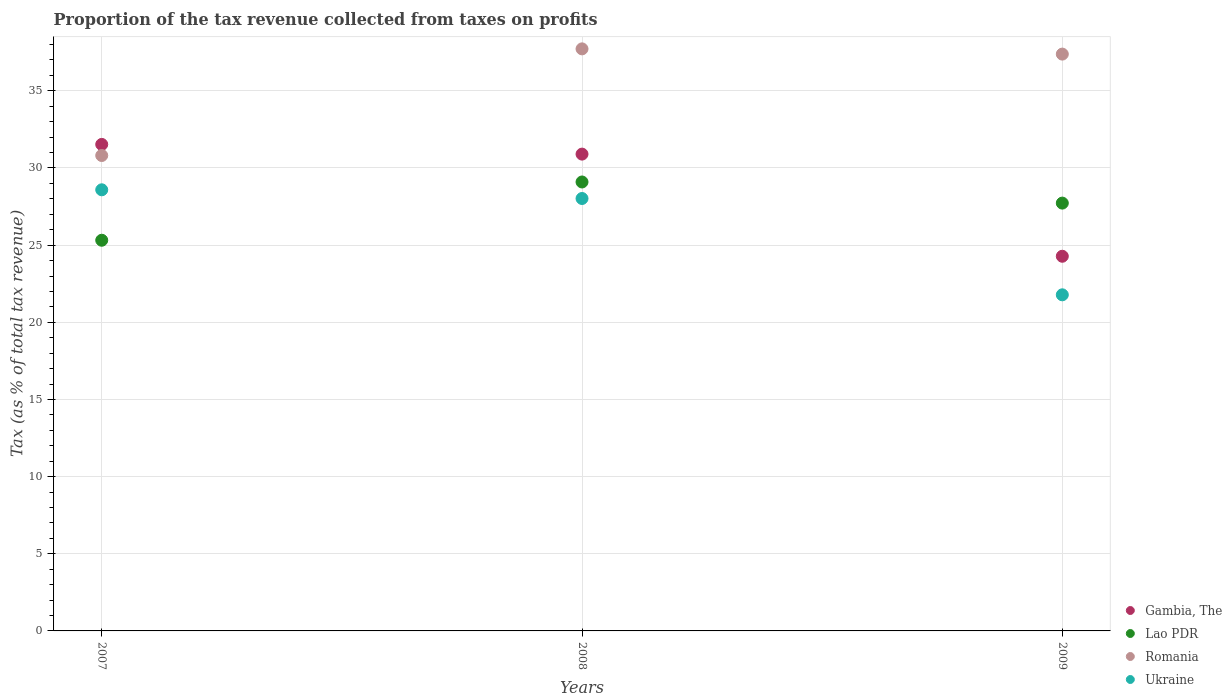Is the number of dotlines equal to the number of legend labels?
Make the answer very short. Yes. What is the proportion of the tax revenue collected in Gambia, The in 2009?
Provide a short and direct response. 24.28. Across all years, what is the maximum proportion of the tax revenue collected in Romania?
Offer a terse response. 37.72. Across all years, what is the minimum proportion of the tax revenue collected in Romania?
Keep it short and to the point. 30.81. In which year was the proportion of the tax revenue collected in Ukraine maximum?
Provide a short and direct response. 2007. In which year was the proportion of the tax revenue collected in Gambia, The minimum?
Ensure brevity in your answer.  2009. What is the total proportion of the tax revenue collected in Gambia, The in the graph?
Give a very brief answer. 86.71. What is the difference between the proportion of the tax revenue collected in Romania in 2008 and that in 2009?
Provide a short and direct response. 0.34. What is the difference between the proportion of the tax revenue collected in Lao PDR in 2009 and the proportion of the tax revenue collected in Romania in 2008?
Your answer should be very brief. -9.99. What is the average proportion of the tax revenue collected in Romania per year?
Your answer should be compact. 35.3. In the year 2008, what is the difference between the proportion of the tax revenue collected in Lao PDR and proportion of the tax revenue collected in Ukraine?
Ensure brevity in your answer.  1.07. What is the ratio of the proportion of the tax revenue collected in Romania in 2008 to that in 2009?
Ensure brevity in your answer.  1.01. Is the proportion of the tax revenue collected in Ukraine in 2007 less than that in 2008?
Keep it short and to the point. No. Is the difference between the proportion of the tax revenue collected in Lao PDR in 2008 and 2009 greater than the difference between the proportion of the tax revenue collected in Ukraine in 2008 and 2009?
Your answer should be very brief. No. What is the difference between the highest and the second highest proportion of the tax revenue collected in Lao PDR?
Offer a terse response. 1.37. What is the difference between the highest and the lowest proportion of the tax revenue collected in Romania?
Offer a very short reply. 6.91. Is the sum of the proportion of the tax revenue collected in Gambia, The in 2007 and 2009 greater than the maximum proportion of the tax revenue collected in Lao PDR across all years?
Give a very brief answer. Yes. Does the proportion of the tax revenue collected in Gambia, The monotonically increase over the years?
Your answer should be very brief. No. Is the proportion of the tax revenue collected in Ukraine strictly greater than the proportion of the tax revenue collected in Gambia, The over the years?
Ensure brevity in your answer.  No. Is the proportion of the tax revenue collected in Gambia, The strictly less than the proportion of the tax revenue collected in Romania over the years?
Offer a very short reply. No. How many dotlines are there?
Give a very brief answer. 4. How many years are there in the graph?
Ensure brevity in your answer.  3. Are the values on the major ticks of Y-axis written in scientific E-notation?
Ensure brevity in your answer.  No. Does the graph contain grids?
Provide a succinct answer. Yes. How are the legend labels stacked?
Provide a succinct answer. Vertical. What is the title of the graph?
Provide a succinct answer. Proportion of the tax revenue collected from taxes on profits. What is the label or title of the X-axis?
Offer a very short reply. Years. What is the label or title of the Y-axis?
Offer a terse response. Tax (as % of total tax revenue). What is the Tax (as % of total tax revenue) of Gambia, The in 2007?
Keep it short and to the point. 31.53. What is the Tax (as % of total tax revenue) in Lao PDR in 2007?
Your answer should be compact. 25.32. What is the Tax (as % of total tax revenue) of Romania in 2007?
Offer a terse response. 30.81. What is the Tax (as % of total tax revenue) in Ukraine in 2007?
Offer a very short reply. 28.59. What is the Tax (as % of total tax revenue) of Gambia, The in 2008?
Your answer should be very brief. 30.9. What is the Tax (as % of total tax revenue) in Lao PDR in 2008?
Your answer should be compact. 29.09. What is the Tax (as % of total tax revenue) of Romania in 2008?
Offer a terse response. 37.72. What is the Tax (as % of total tax revenue) in Ukraine in 2008?
Give a very brief answer. 28.02. What is the Tax (as % of total tax revenue) of Gambia, The in 2009?
Keep it short and to the point. 24.28. What is the Tax (as % of total tax revenue) of Lao PDR in 2009?
Your answer should be very brief. 27.72. What is the Tax (as % of total tax revenue) in Romania in 2009?
Make the answer very short. 37.38. What is the Tax (as % of total tax revenue) of Ukraine in 2009?
Offer a very short reply. 21.78. Across all years, what is the maximum Tax (as % of total tax revenue) of Gambia, The?
Provide a succinct answer. 31.53. Across all years, what is the maximum Tax (as % of total tax revenue) of Lao PDR?
Your answer should be compact. 29.09. Across all years, what is the maximum Tax (as % of total tax revenue) of Romania?
Provide a short and direct response. 37.72. Across all years, what is the maximum Tax (as % of total tax revenue) in Ukraine?
Provide a short and direct response. 28.59. Across all years, what is the minimum Tax (as % of total tax revenue) of Gambia, The?
Provide a short and direct response. 24.28. Across all years, what is the minimum Tax (as % of total tax revenue) of Lao PDR?
Provide a succinct answer. 25.32. Across all years, what is the minimum Tax (as % of total tax revenue) of Romania?
Ensure brevity in your answer.  30.81. Across all years, what is the minimum Tax (as % of total tax revenue) in Ukraine?
Ensure brevity in your answer.  21.78. What is the total Tax (as % of total tax revenue) of Gambia, The in the graph?
Make the answer very short. 86.71. What is the total Tax (as % of total tax revenue) in Lao PDR in the graph?
Offer a very short reply. 82.14. What is the total Tax (as % of total tax revenue) of Romania in the graph?
Offer a terse response. 105.91. What is the total Tax (as % of total tax revenue) in Ukraine in the graph?
Provide a succinct answer. 78.39. What is the difference between the Tax (as % of total tax revenue) of Gambia, The in 2007 and that in 2008?
Your answer should be very brief. 0.63. What is the difference between the Tax (as % of total tax revenue) in Lao PDR in 2007 and that in 2008?
Keep it short and to the point. -3.78. What is the difference between the Tax (as % of total tax revenue) of Romania in 2007 and that in 2008?
Your answer should be compact. -6.91. What is the difference between the Tax (as % of total tax revenue) of Ukraine in 2007 and that in 2008?
Ensure brevity in your answer.  0.56. What is the difference between the Tax (as % of total tax revenue) in Gambia, The in 2007 and that in 2009?
Offer a very short reply. 7.25. What is the difference between the Tax (as % of total tax revenue) in Lao PDR in 2007 and that in 2009?
Keep it short and to the point. -2.41. What is the difference between the Tax (as % of total tax revenue) of Romania in 2007 and that in 2009?
Give a very brief answer. -6.57. What is the difference between the Tax (as % of total tax revenue) in Ukraine in 2007 and that in 2009?
Provide a short and direct response. 6.81. What is the difference between the Tax (as % of total tax revenue) in Gambia, The in 2008 and that in 2009?
Ensure brevity in your answer.  6.62. What is the difference between the Tax (as % of total tax revenue) in Lao PDR in 2008 and that in 2009?
Ensure brevity in your answer.  1.37. What is the difference between the Tax (as % of total tax revenue) of Romania in 2008 and that in 2009?
Keep it short and to the point. 0.34. What is the difference between the Tax (as % of total tax revenue) in Ukraine in 2008 and that in 2009?
Provide a succinct answer. 6.24. What is the difference between the Tax (as % of total tax revenue) in Gambia, The in 2007 and the Tax (as % of total tax revenue) in Lao PDR in 2008?
Provide a succinct answer. 2.43. What is the difference between the Tax (as % of total tax revenue) of Gambia, The in 2007 and the Tax (as % of total tax revenue) of Romania in 2008?
Offer a very short reply. -6.19. What is the difference between the Tax (as % of total tax revenue) of Gambia, The in 2007 and the Tax (as % of total tax revenue) of Ukraine in 2008?
Your answer should be very brief. 3.51. What is the difference between the Tax (as % of total tax revenue) of Lao PDR in 2007 and the Tax (as % of total tax revenue) of Romania in 2008?
Provide a short and direct response. -12.4. What is the difference between the Tax (as % of total tax revenue) in Lao PDR in 2007 and the Tax (as % of total tax revenue) in Ukraine in 2008?
Your answer should be very brief. -2.71. What is the difference between the Tax (as % of total tax revenue) of Romania in 2007 and the Tax (as % of total tax revenue) of Ukraine in 2008?
Provide a short and direct response. 2.79. What is the difference between the Tax (as % of total tax revenue) of Gambia, The in 2007 and the Tax (as % of total tax revenue) of Lao PDR in 2009?
Keep it short and to the point. 3.8. What is the difference between the Tax (as % of total tax revenue) in Gambia, The in 2007 and the Tax (as % of total tax revenue) in Romania in 2009?
Give a very brief answer. -5.85. What is the difference between the Tax (as % of total tax revenue) of Gambia, The in 2007 and the Tax (as % of total tax revenue) of Ukraine in 2009?
Ensure brevity in your answer.  9.75. What is the difference between the Tax (as % of total tax revenue) of Lao PDR in 2007 and the Tax (as % of total tax revenue) of Romania in 2009?
Offer a very short reply. -12.06. What is the difference between the Tax (as % of total tax revenue) of Lao PDR in 2007 and the Tax (as % of total tax revenue) of Ukraine in 2009?
Provide a short and direct response. 3.54. What is the difference between the Tax (as % of total tax revenue) in Romania in 2007 and the Tax (as % of total tax revenue) in Ukraine in 2009?
Your answer should be compact. 9.03. What is the difference between the Tax (as % of total tax revenue) in Gambia, The in 2008 and the Tax (as % of total tax revenue) in Lao PDR in 2009?
Provide a succinct answer. 3.17. What is the difference between the Tax (as % of total tax revenue) of Gambia, The in 2008 and the Tax (as % of total tax revenue) of Romania in 2009?
Offer a very short reply. -6.48. What is the difference between the Tax (as % of total tax revenue) in Gambia, The in 2008 and the Tax (as % of total tax revenue) in Ukraine in 2009?
Offer a terse response. 9.12. What is the difference between the Tax (as % of total tax revenue) of Lao PDR in 2008 and the Tax (as % of total tax revenue) of Romania in 2009?
Give a very brief answer. -8.29. What is the difference between the Tax (as % of total tax revenue) in Lao PDR in 2008 and the Tax (as % of total tax revenue) in Ukraine in 2009?
Offer a terse response. 7.31. What is the difference between the Tax (as % of total tax revenue) in Romania in 2008 and the Tax (as % of total tax revenue) in Ukraine in 2009?
Your response must be concise. 15.94. What is the average Tax (as % of total tax revenue) of Gambia, The per year?
Your answer should be compact. 28.9. What is the average Tax (as % of total tax revenue) of Lao PDR per year?
Keep it short and to the point. 27.38. What is the average Tax (as % of total tax revenue) in Romania per year?
Your response must be concise. 35.3. What is the average Tax (as % of total tax revenue) of Ukraine per year?
Provide a short and direct response. 26.13. In the year 2007, what is the difference between the Tax (as % of total tax revenue) of Gambia, The and Tax (as % of total tax revenue) of Lao PDR?
Keep it short and to the point. 6.21. In the year 2007, what is the difference between the Tax (as % of total tax revenue) in Gambia, The and Tax (as % of total tax revenue) in Romania?
Offer a very short reply. 0.72. In the year 2007, what is the difference between the Tax (as % of total tax revenue) in Gambia, The and Tax (as % of total tax revenue) in Ukraine?
Your response must be concise. 2.94. In the year 2007, what is the difference between the Tax (as % of total tax revenue) of Lao PDR and Tax (as % of total tax revenue) of Romania?
Provide a short and direct response. -5.49. In the year 2007, what is the difference between the Tax (as % of total tax revenue) of Lao PDR and Tax (as % of total tax revenue) of Ukraine?
Offer a very short reply. -3.27. In the year 2007, what is the difference between the Tax (as % of total tax revenue) in Romania and Tax (as % of total tax revenue) in Ukraine?
Provide a succinct answer. 2.22. In the year 2008, what is the difference between the Tax (as % of total tax revenue) in Gambia, The and Tax (as % of total tax revenue) in Lao PDR?
Ensure brevity in your answer.  1.81. In the year 2008, what is the difference between the Tax (as % of total tax revenue) of Gambia, The and Tax (as % of total tax revenue) of Romania?
Your answer should be compact. -6.82. In the year 2008, what is the difference between the Tax (as % of total tax revenue) in Gambia, The and Tax (as % of total tax revenue) in Ukraine?
Offer a very short reply. 2.88. In the year 2008, what is the difference between the Tax (as % of total tax revenue) of Lao PDR and Tax (as % of total tax revenue) of Romania?
Provide a succinct answer. -8.63. In the year 2008, what is the difference between the Tax (as % of total tax revenue) of Lao PDR and Tax (as % of total tax revenue) of Ukraine?
Provide a short and direct response. 1.07. In the year 2008, what is the difference between the Tax (as % of total tax revenue) in Romania and Tax (as % of total tax revenue) in Ukraine?
Offer a terse response. 9.7. In the year 2009, what is the difference between the Tax (as % of total tax revenue) in Gambia, The and Tax (as % of total tax revenue) in Lao PDR?
Keep it short and to the point. -3.44. In the year 2009, what is the difference between the Tax (as % of total tax revenue) in Gambia, The and Tax (as % of total tax revenue) in Romania?
Provide a succinct answer. -13.1. In the year 2009, what is the difference between the Tax (as % of total tax revenue) of Gambia, The and Tax (as % of total tax revenue) of Ukraine?
Provide a succinct answer. 2.5. In the year 2009, what is the difference between the Tax (as % of total tax revenue) in Lao PDR and Tax (as % of total tax revenue) in Romania?
Offer a very short reply. -9.66. In the year 2009, what is the difference between the Tax (as % of total tax revenue) of Lao PDR and Tax (as % of total tax revenue) of Ukraine?
Your answer should be compact. 5.94. In the year 2009, what is the difference between the Tax (as % of total tax revenue) in Romania and Tax (as % of total tax revenue) in Ukraine?
Make the answer very short. 15.6. What is the ratio of the Tax (as % of total tax revenue) of Gambia, The in 2007 to that in 2008?
Provide a short and direct response. 1.02. What is the ratio of the Tax (as % of total tax revenue) of Lao PDR in 2007 to that in 2008?
Offer a very short reply. 0.87. What is the ratio of the Tax (as % of total tax revenue) of Romania in 2007 to that in 2008?
Ensure brevity in your answer.  0.82. What is the ratio of the Tax (as % of total tax revenue) in Ukraine in 2007 to that in 2008?
Make the answer very short. 1.02. What is the ratio of the Tax (as % of total tax revenue) in Gambia, The in 2007 to that in 2009?
Your answer should be very brief. 1.3. What is the ratio of the Tax (as % of total tax revenue) in Lao PDR in 2007 to that in 2009?
Your answer should be compact. 0.91. What is the ratio of the Tax (as % of total tax revenue) of Romania in 2007 to that in 2009?
Provide a short and direct response. 0.82. What is the ratio of the Tax (as % of total tax revenue) in Ukraine in 2007 to that in 2009?
Offer a very short reply. 1.31. What is the ratio of the Tax (as % of total tax revenue) in Gambia, The in 2008 to that in 2009?
Offer a terse response. 1.27. What is the ratio of the Tax (as % of total tax revenue) in Lao PDR in 2008 to that in 2009?
Your answer should be compact. 1.05. What is the ratio of the Tax (as % of total tax revenue) of Romania in 2008 to that in 2009?
Your response must be concise. 1.01. What is the ratio of the Tax (as % of total tax revenue) in Ukraine in 2008 to that in 2009?
Make the answer very short. 1.29. What is the difference between the highest and the second highest Tax (as % of total tax revenue) in Gambia, The?
Ensure brevity in your answer.  0.63. What is the difference between the highest and the second highest Tax (as % of total tax revenue) of Lao PDR?
Ensure brevity in your answer.  1.37. What is the difference between the highest and the second highest Tax (as % of total tax revenue) in Romania?
Your response must be concise. 0.34. What is the difference between the highest and the second highest Tax (as % of total tax revenue) of Ukraine?
Ensure brevity in your answer.  0.56. What is the difference between the highest and the lowest Tax (as % of total tax revenue) of Gambia, The?
Make the answer very short. 7.25. What is the difference between the highest and the lowest Tax (as % of total tax revenue) in Lao PDR?
Offer a terse response. 3.78. What is the difference between the highest and the lowest Tax (as % of total tax revenue) in Romania?
Provide a succinct answer. 6.91. What is the difference between the highest and the lowest Tax (as % of total tax revenue) in Ukraine?
Keep it short and to the point. 6.81. 